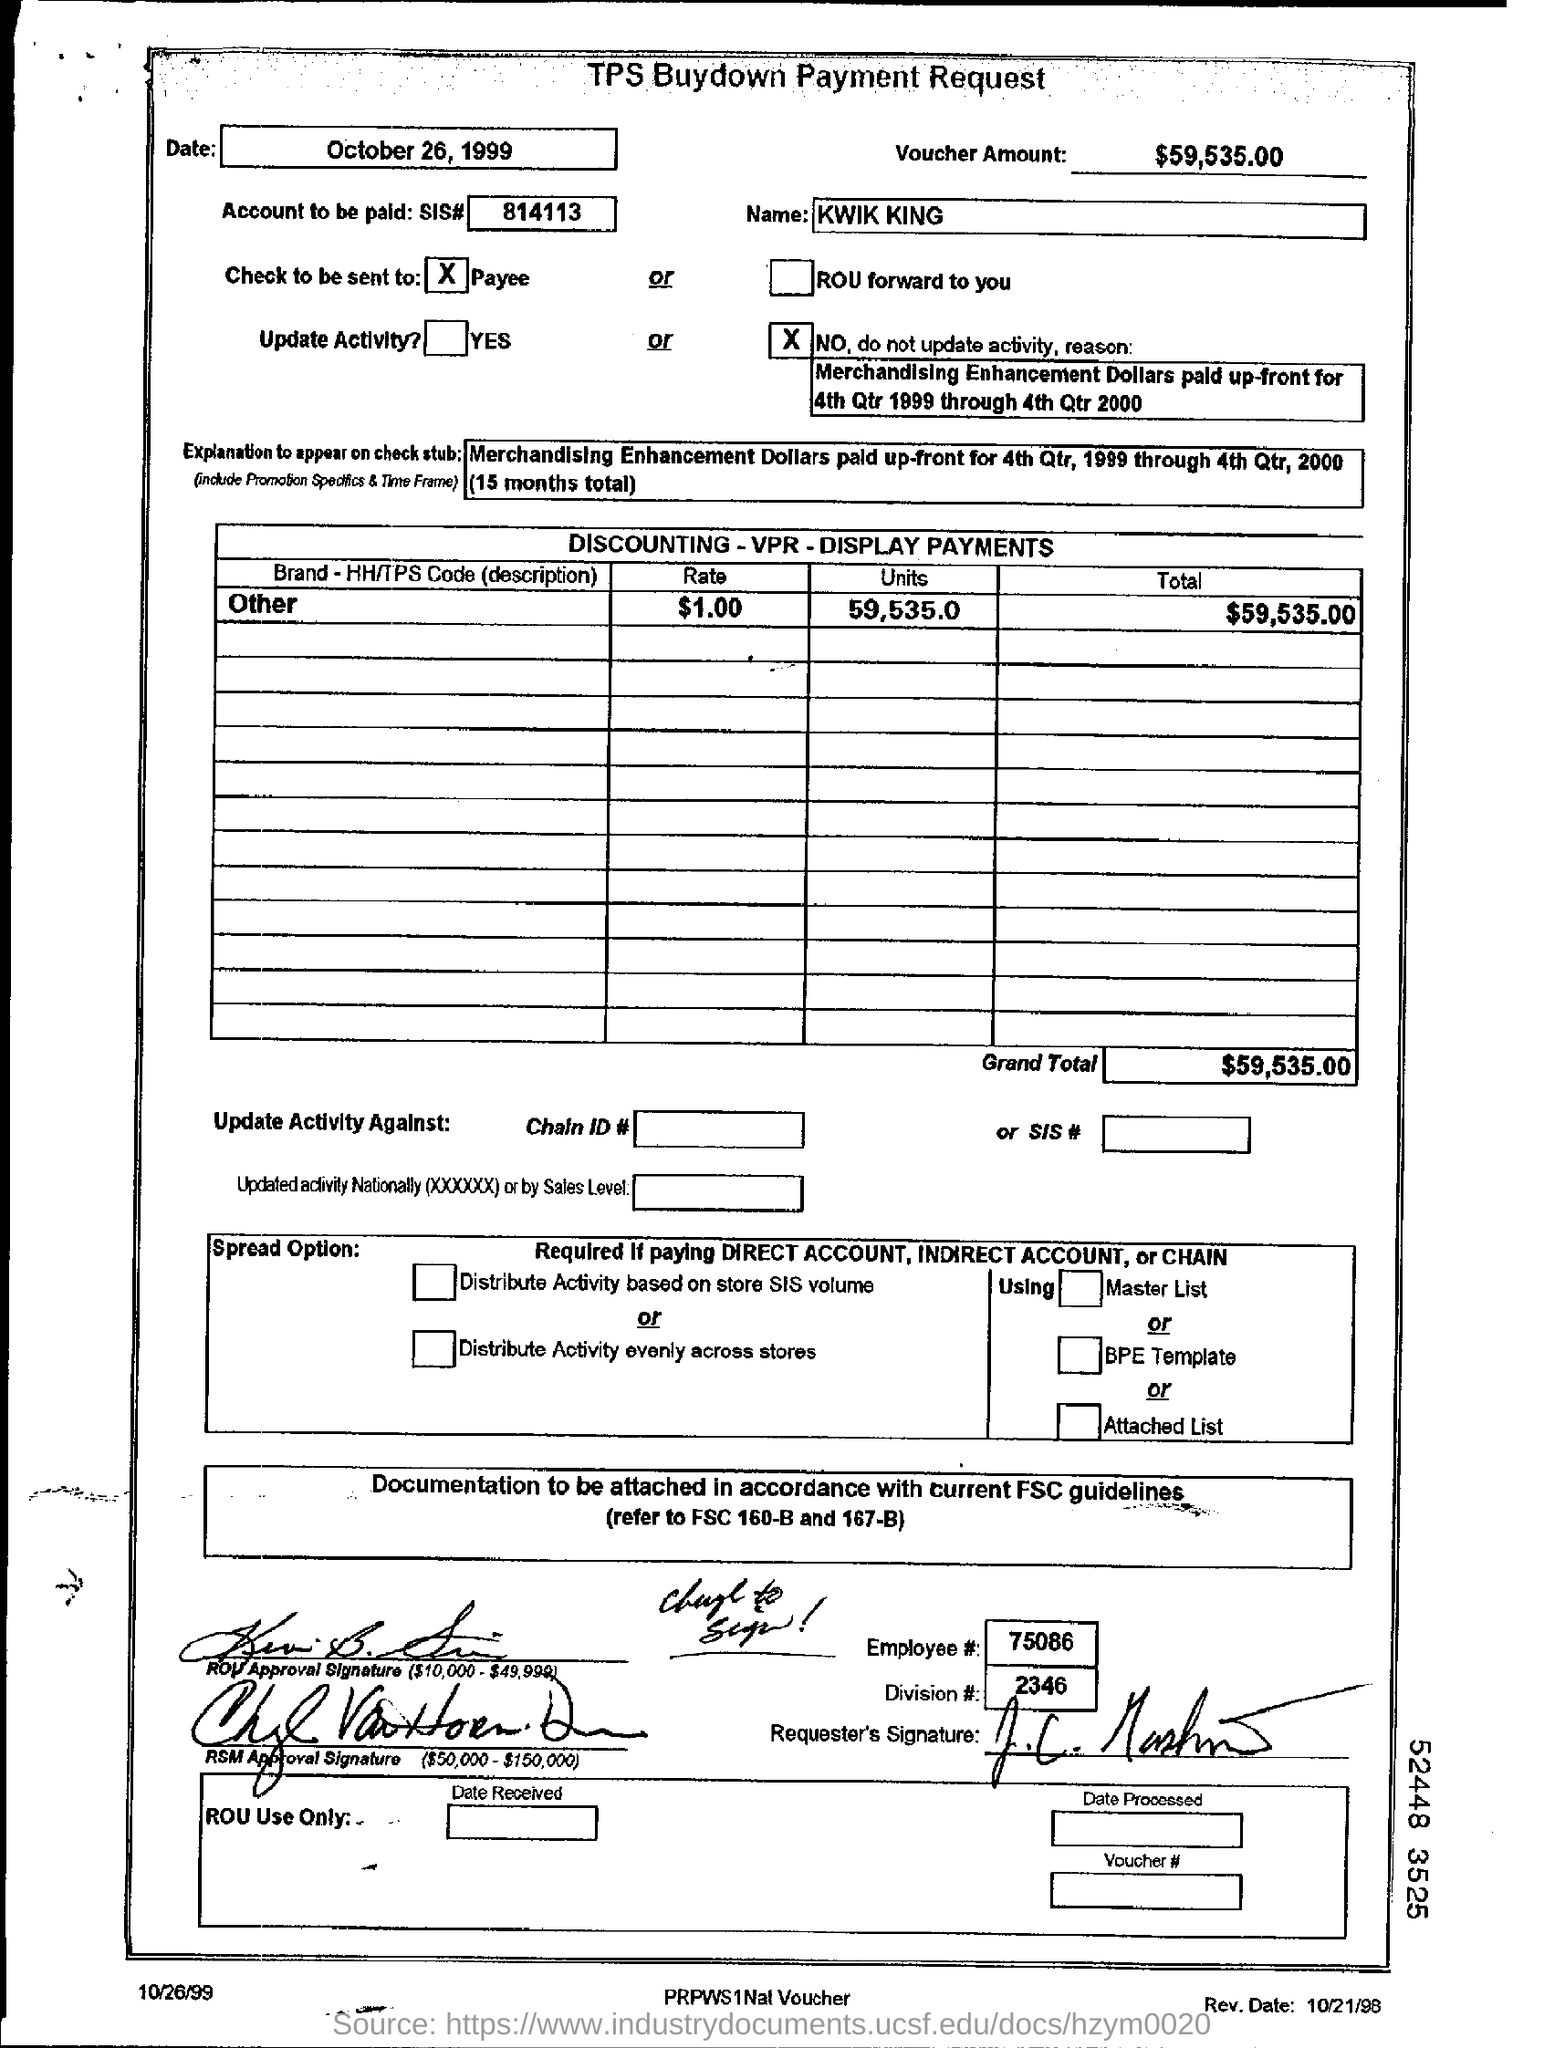What does the term 'buydown' refer to in this context? In this context, 'buydown' typically refers to a financial arrangement where a payment is made upfront to reduce the cost of an item or service for a promotional period. This tactic is often used in merchandising to temporarily lower prices to the consumer, which can stimulate sales or move inventory quickly. 